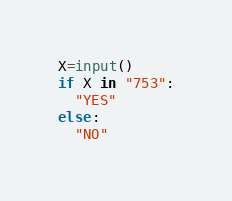<code> <loc_0><loc_0><loc_500><loc_500><_Python_>X=input()
if X in "753":
  "YES"
else:
  "NO"</code> 